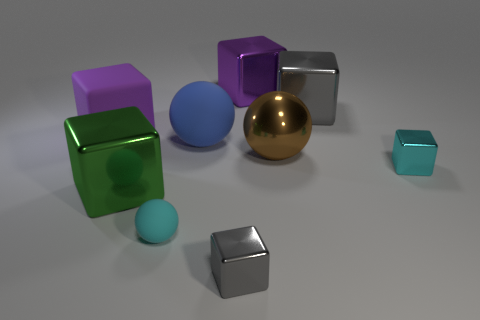There is a tiny block to the left of the brown object; is its color the same as the big object that is right of the metal sphere?
Your response must be concise. Yes. What size is the thing that is the same color as the small rubber sphere?
Your answer should be very brief. Small. There is a brown object that is the same material as the tiny gray cube; what size is it?
Make the answer very short. Large. What size is the cyan metallic object?
Your answer should be compact. Small. The green shiny thing is what shape?
Make the answer very short. Cube. Is the color of the small block behind the cyan matte thing the same as the tiny rubber object?
Your answer should be very brief. Yes. What size is the cyan object that is the same shape as the purple shiny object?
Give a very brief answer. Small. Are there any metallic blocks that are behind the metallic thing right of the big cube that is to the right of the brown metal object?
Ensure brevity in your answer.  Yes. There is a small cyan object that is on the right side of the blue rubber ball; what is its material?
Make the answer very short. Metal. What number of large objects are either metal blocks or cyan spheres?
Offer a terse response. 3. 